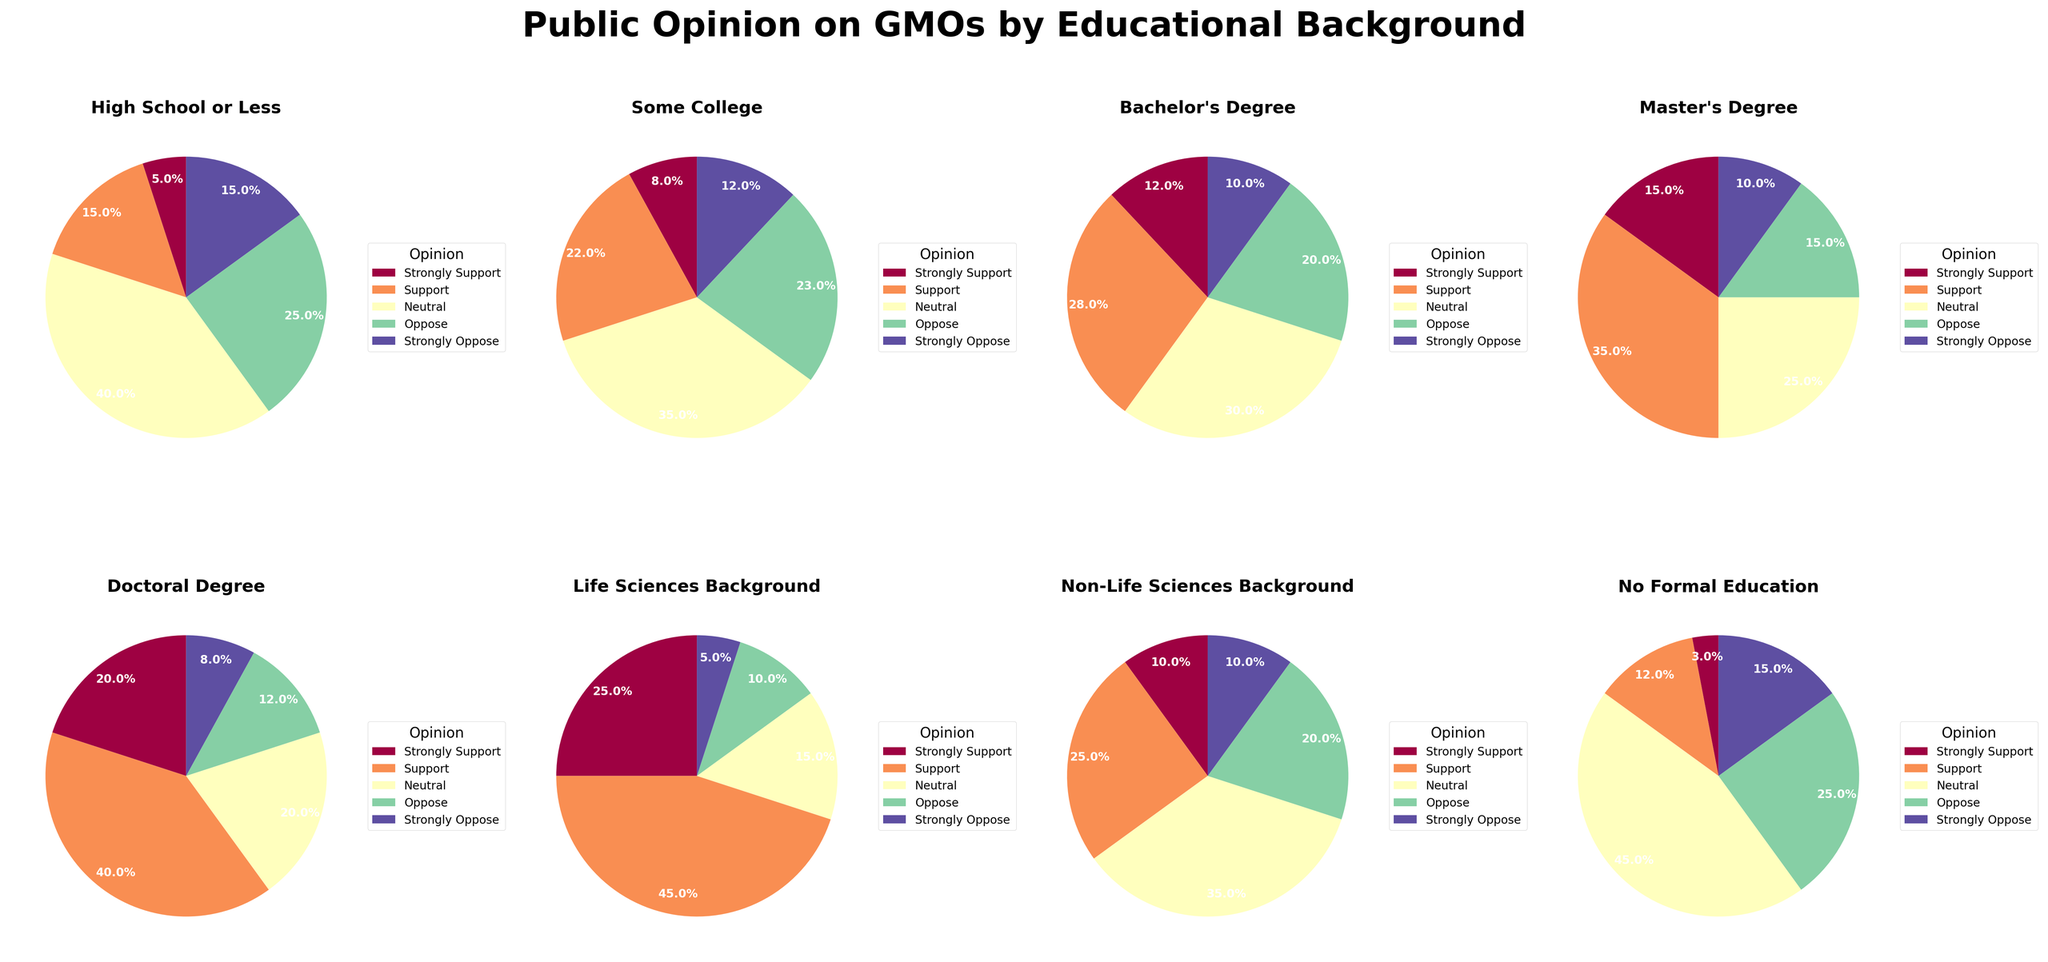Which educational background group shows the highest percentage of "Strongly Support" for GMOs? The pie chart for each educational background is represented separately. By visually inspecting the wedges for “Strongly Support” (red portion), the Doctoral Degree group has the largest wedge for this opinion category.
Answer: Doctoral Degree Among those with a Master's Degree, which opinion category has the lowest percentage? For the Master's Degree subgroup, the pie chart shows that "Strongly Oppose" has the smallest wedge, represented by the blue color.
Answer: Strongly Oppose What is the percentage difference in "Neutral" opinion between those with Some College education and those with a Life Sciences Background? The Some College subgroup's pie shows that "Neutral" (green portion) is 35%. The Life Sciences Background subgroup's pie shows "Neutral" is 15%. The difference is 35% - 15%.
Answer: 20% Compare the "Oppose" opinions between Non-Life Sciences Background and No Formal Education. Which group has a higher percentage, and by how much? The Non-Life Sciences Background subgroup shows "Oppose" (orange portion) is 20%. The No Formal Education subgroup shows "Oppose" is 25%. So No Formal Education is higher by 25% - 20%.
Answer: No Formal Education, 5% Given the total percentage of "Support" and "Strongly Support", which educational subgroup shows overwhelming support for GMOs? By adding the percentages of "Support" (light red) and "Strongly Support" (red), the Life Sciences Background subgroup sums up to 45% + 25% = 70%. This is the highest among all subgroups.
Answer: Life Sciences Background Among those with a High School education or less, by what factor is the "Neutral" opinion higher than the "Strongly Support" opinion? For High School or less, "Neutral" is 40% and "Strongly Support" is 5%. The factor is 40% / 5%.
Answer: 8 times In which educational subgroup are the "Strongly Oppose" opinions and "Oppose" opinions exactly equal? By visually inspecting the wedges for "Strongly Oppose" (blue) and "Oppose" (orange), we find that No Formal Education subgroup has both at 15%.
Answer: No Formal Education Compare the total "Oppose" and "Strongly Oppose" opinions between those with a Bachelor's Degree and those with a Master's Degree. Which group shows less opposition and by how much? Adding "Oppose" and "Strongly Oppose" for Bachelor's Degree subgroup: 20% + 10% = 30%. For Master's Degree: 15% + 10% = 25%. The Bachelor's Degree group shows more opposition by 30% - 25%.
Answer: Master's Degree, 5% Which subgroup shows a close percentage of "Support" and "Oppose" opinions? By visually comparing the Support (light red) and Oppose (orange) wedges, the Some College subgroup has 22% Support and 23% Oppose, which are very close.
Answer: Some College For those with a Doctoral Degree, what is the combined percentage of "Neutral" and "Oppose" opinions? The Doctoral Degree subgroup shows 20% for "Neutral" (green part) and 12% for "Oppose" (orange part). The combined percentage is 20% + 12%.
Answer: 32% 